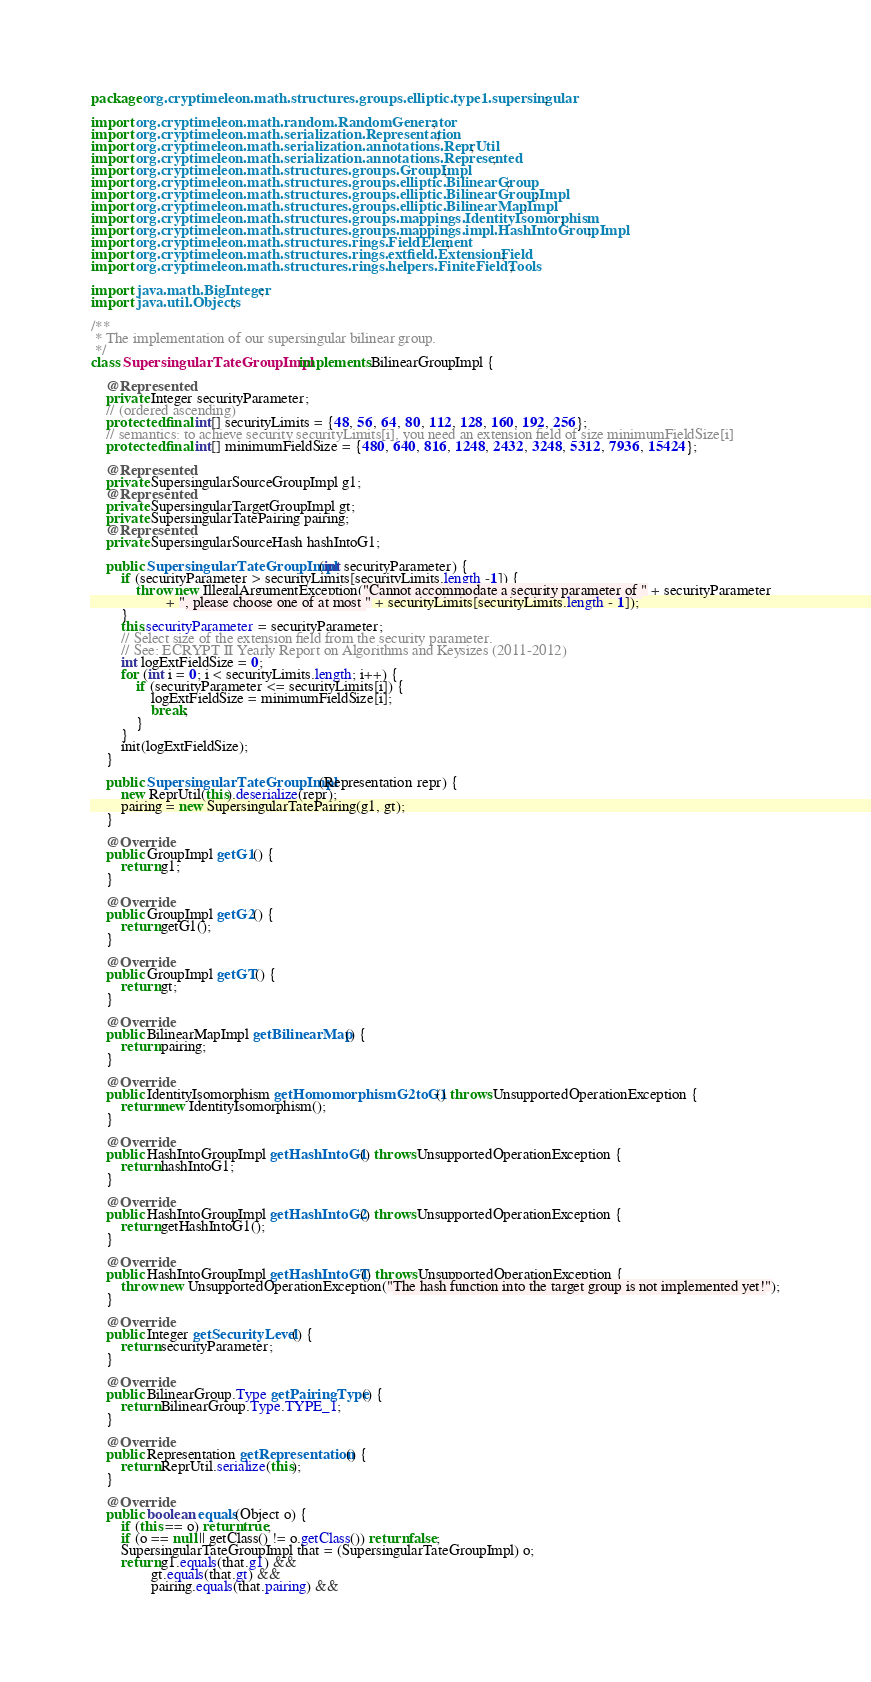<code> <loc_0><loc_0><loc_500><loc_500><_Java_>package org.cryptimeleon.math.structures.groups.elliptic.type1.supersingular;

import org.cryptimeleon.math.random.RandomGenerator;
import org.cryptimeleon.math.serialization.Representation;
import org.cryptimeleon.math.serialization.annotations.ReprUtil;
import org.cryptimeleon.math.serialization.annotations.Represented;
import org.cryptimeleon.math.structures.groups.GroupImpl;
import org.cryptimeleon.math.structures.groups.elliptic.BilinearGroup;
import org.cryptimeleon.math.structures.groups.elliptic.BilinearGroupImpl;
import org.cryptimeleon.math.structures.groups.elliptic.BilinearMapImpl;
import org.cryptimeleon.math.structures.groups.mappings.IdentityIsomorphism;
import org.cryptimeleon.math.structures.groups.mappings.impl.HashIntoGroupImpl;
import org.cryptimeleon.math.structures.rings.FieldElement;
import org.cryptimeleon.math.structures.rings.extfield.ExtensionField;
import org.cryptimeleon.math.structures.rings.helpers.FiniteFieldTools;

import java.math.BigInteger;
import java.util.Objects;

/**
 * The implementation of our supersingular bilinear group.
 */
class SupersingularTateGroupImpl implements BilinearGroupImpl {

    @Represented
    private Integer securityParameter;
    // (ordered ascending)
    protected final int[] securityLimits = {48, 56, 64, 80, 112, 128, 160, 192, 256};
    // semantics: to achieve security securityLimits[i], you need an extension field of size minimumFieldSize[i]
    protected final int[] minimumFieldSize = {480, 640, 816, 1248, 2432, 3248, 5312, 7936, 15424};

    @Represented
    private SupersingularSourceGroupImpl g1;
    @Represented
    private SupersingularTargetGroupImpl gt;
    private SupersingularTatePairing pairing;
    @Represented
    private SupersingularSourceHash hashIntoG1;

    public SupersingularTateGroupImpl(int securityParameter) {
        if (securityParameter > securityLimits[securityLimits.length -1]) {
            throw new IllegalArgumentException("Cannot accommodate a security parameter of " + securityParameter
                    + ", please choose one of at most " + securityLimits[securityLimits.length - 1]);
        }
        this.securityParameter = securityParameter;
        // Select size of the extension field from the security parameter.
        // See: ECRYPT II Yearly Report on Algorithms and Keysizes (2011-2012)
        int logExtFieldSize = 0;
        for (int i = 0; i < securityLimits.length; i++) {
            if (securityParameter <= securityLimits[i]) {
                logExtFieldSize = minimumFieldSize[i];
                break;
            }
        }
        init(logExtFieldSize);
    }

    public SupersingularTateGroupImpl(Representation repr) {
        new ReprUtil(this).deserialize(repr);
        pairing = new SupersingularTatePairing(g1, gt);
    }

    @Override
    public GroupImpl getG1() {
        return g1;
    }

    @Override
    public GroupImpl getG2() {
        return getG1();
    }

    @Override
    public GroupImpl getGT() {
        return gt;
    }

    @Override
    public BilinearMapImpl getBilinearMap() {
        return pairing;
    }

    @Override
    public IdentityIsomorphism getHomomorphismG2toG1() throws UnsupportedOperationException {
        return new IdentityIsomorphism();
    }

    @Override
    public HashIntoGroupImpl getHashIntoG1() throws UnsupportedOperationException {
        return hashIntoG1;
    }

    @Override
    public HashIntoGroupImpl getHashIntoG2() throws UnsupportedOperationException {
        return getHashIntoG1();
    }

    @Override
    public HashIntoGroupImpl getHashIntoGT() throws UnsupportedOperationException {
        throw new UnsupportedOperationException("The hash function into the target group is not implemented yet!");
    }

    @Override
    public Integer getSecurityLevel() {
        return securityParameter;
    }

    @Override
    public BilinearGroup.Type getPairingType() {
        return BilinearGroup.Type.TYPE_1;
    }

    @Override
    public Representation getRepresentation() {
        return ReprUtil.serialize(this);
    }

    @Override
    public boolean equals(Object o) {
        if (this == o) return true;
        if (o == null || getClass() != o.getClass()) return false;
        SupersingularTateGroupImpl that = (SupersingularTateGroupImpl) o;
        return g1.equals(that.g1) &&
                gt.equals(that.gt) &&
                pairing.equals(that.pairing) &&</code> 